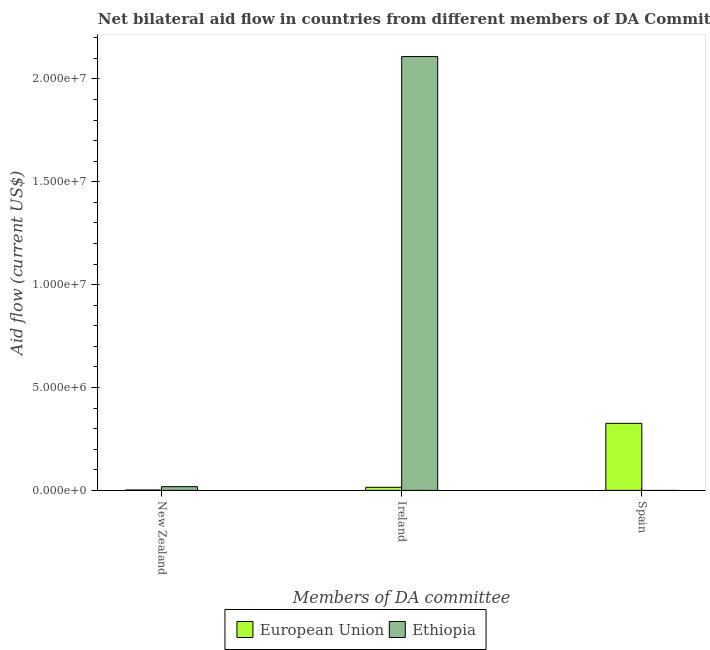How many different coloured bars are there?
Provide a short and direct response. 2. Are the number of bars per tick equal to the number of legend labels?
Provide a succinct answer. No. Are the number of bars on each tick of the X-axis equal?
Give a very brief answer. No. How many bars are there on the 1st tick from the left?
Make the answer very short. 2. How many bars are there on the 3rd tick from the right?
Provide a short and direct response. 2. What is the label of the 3rd group of bars from the left?
Make the answer very short. Spain. What is the amount of aid provided by spain in European Union?
Your answer should be very brief. 3.26e+06. Across all countries, what is the maximum amount of aid provided by spain?
Your answer should be compact. 3.26e+06. Across all countries, what is the minimum amount of aid provided by ireland?
Provide a short and direct response. 1.50e+05. In which country was the amount of aid provided by ireland maximum?
Offer a very short reply. Ethiopia. What is the total amount of aid provided by new zealand in the graph?
Provide a succinct answer. 2.00e+05. What is the difference between the amount of aid provided by ireland in Ethiopia and that in European Union?
Your answer should be very brief. 2.09e+07. What is the difference between the amount of aid provided by spain in Ethiopia and the amount of aid provided by ireland in European Union?
Your response must be concise. -1.50e+05. What is the average amount of aid provided by spain per country?
Provide a short and direct response. 1.63e+06. What is the difference between the amount of aid provided by ireland and amount of aid provided by spain in European Union?
Your response must be concise. -3.11e+06. In how many countries, is the amount of aid provided by spain greater than 19000000 US$?
Offer a terse response. 0. What is the ratio of the amount of aid provided by ireland in Ethiopia to that in European Union?
Provide a succinct answer. 140.6. What is the difference between the highest and the second highest amount of aid provided by new zealand?
Give a very brief answer. 1.60e+05. What is the difference between the highest and the lowest amount of aid provided by spain?
Give a very brief answer. 3.26e+06. Is it the case that in every country, the sum of the amount of aid provided by new zealand and amount of aid provided by ireland is greater than the amount of aid provided by spain?
Offer a very short reply. No. How many countries are there in the graph?
Ensure brevity in your answer.  2. What is the difference between two consecutive major ticks on the Y-axis?
Your answer should be compact. 5.00e+06. Does the graph contain grids?
Provide a short and direct response. No. Where does the legend appear in the graph?
Keep it short and to the point. Bottom center. What is the title of the graph?
Give a very brief answer. Net bilateral aid flow in countries from different members of DA Committee. What is the label or title of the X-axis?
Your answer should be compact. Members of DA committee. What is the label or title of the Y-axis?
Ensure brevity in your answer.  Aid flow (current US$). What is the Aid flow (current US$) of European Union in New Zealand?
Provide a short and direct response. 2.00e+04. What is the Aid flow (current US$) in Ethiopia in New Zealand?
Your answer should be compact. 1.80e+05. What is the Aid flow (current US$) in European Union in Ireland?
Make the answer very short. 1.50e+05. What is the Aid flow (current US$) in Ethiopia in Ireland?
Your answer should be very brief. 2.11e+07. What is the Aid flow (current US$) in European Union in Spain?
Your response must be concise. 3.26e+06. What is the Aid flow (current US$) in Ethiopia in Spain?
Your answer should be very brief. 0. Across all Members of DA committee, what is the maximum Aid flow (current US$) in European Union?
Provide a succinct answer. 3.26e+06. Across all Members of DA committee, what is the maximum Aid flow (current US$) of Ethiopia?
Keep it short and to the point. 2.11e+07. Across all Members of DA committee, what is the minimum Aid flow (current US$) of Ethiopia?
Make the answer very short. 0. What is the total Aid flow (current US$) of European Union in the graph?
Make the answer very short. 3.43e+06. What is the total Aid flow (current US$) of Ethiopia in the graph?
Offer a very short reply. 2.13e+07. What is the difference between the Aid flow (current US$) in Ethiopia in New Zealand and that in Ireland?
Keep it short and to the point. -2.09e+07. What is the difference between the Aid flow (current US$) in European Union in New Zealand and that in Spain?
Keep it short and to the point. -3.24e+06. What is the difference between the Aid flow (current US$) in European Union in Ireland and that in Spain?
Give a very brief answer. -3.11e+06. What is the difference between the Aid flow (current US$) in European Union in New Zealand and the Aid flow (current US$) in Ethiopia in Ireland?
Provide a short and direct response. -2.11e+07. What is the average Aid flow (current US$) of European Union per Members of DA committee?
Your answer should be very brief. 1.14e+06. What is the average Aid flow (current US$) of Ethiopia per Members of DA committee?
Offer a very short reply. 7.09e+06. What is the difference between the Aid flow (current US$) of European Union and Aid flow (current US$) of Ethiopia in Ireland?
Ensure brevity in your answer.  -2.09e+07. What is the ratio of the Aid flow (current US$) in European Union in New Zealand to that in Ireland?
Give a very brief answer. 0.13. What is the ratio of the Aid flow (current US$) in Ethiopia in New Zealand to that in Ireland?
Provide a short and direct response. 0.01. What is the ratio of the Aid flow (current US$) of European Union in New Zealand to that in Spain?
Keep it short and to the point. 0.01. What is the ratio of the Aid flow (current US$) of European Union in Ireland to that in Spain?
Give a very brief answer. 0.05. What is the difference between the highest and the second highest Aid flow (current US$) of European Union?
Ensure brevity in your answer.  3.11e+06. What is the difference between the highest and the lowest Aid flow (current US$) in European Union?
Provide a short and direct response. 3.24e+06. What is the difference between the highest and the lowest Aid flow (current US$) in Ethiopia?
Make the answer very short. 2.11e+07. 